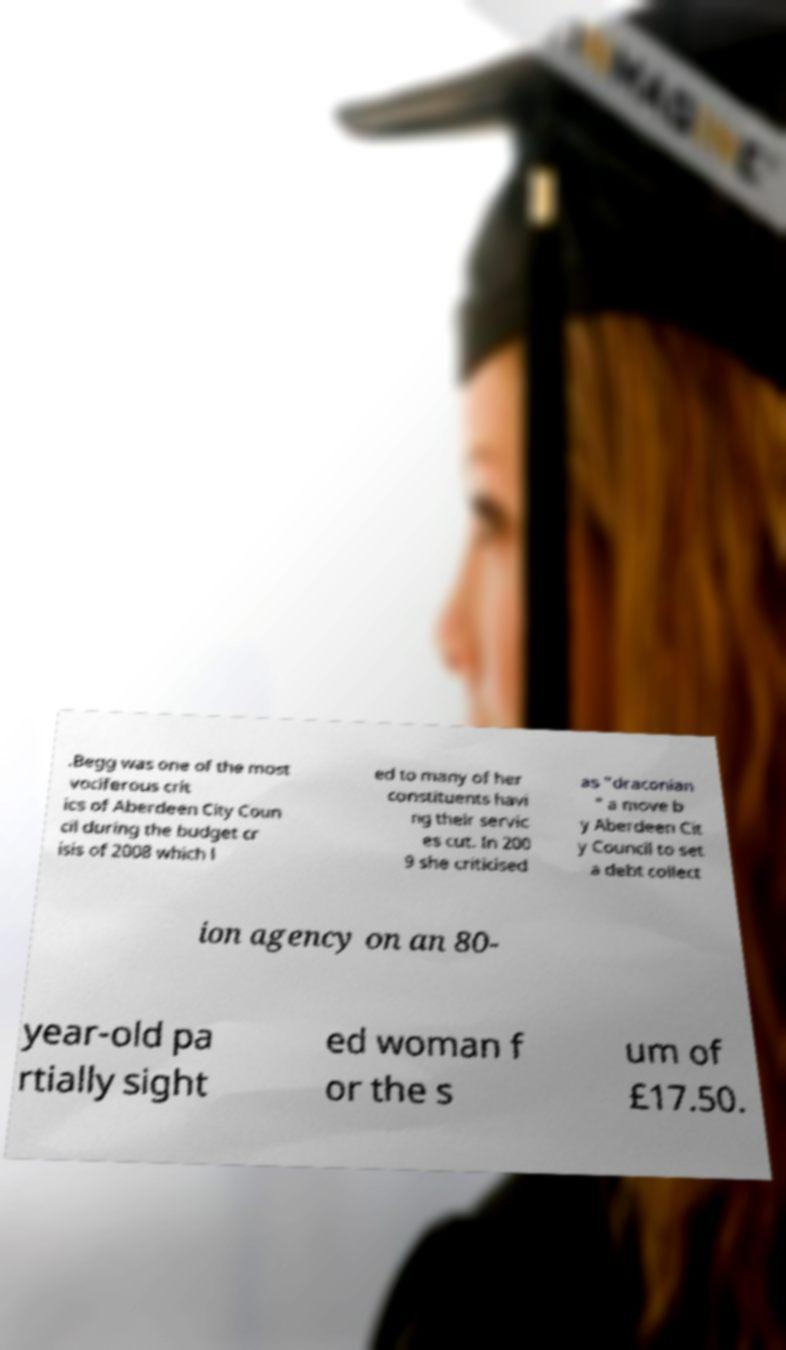Please identify and transcribe the text found in this image. .Begg was one of the most vociferous crit ics of Aberdeen City Coun cil during the budget cr isis of 2008 which l ed to many of her constituents havi ng their servic es cut. In 200 9 she criticised as "draconian " a move b y Aberdeen Cit y Council to set a debt collect ion agency on an 80- year-old pa rtially sight ed woman f or the s um of £17.50. 